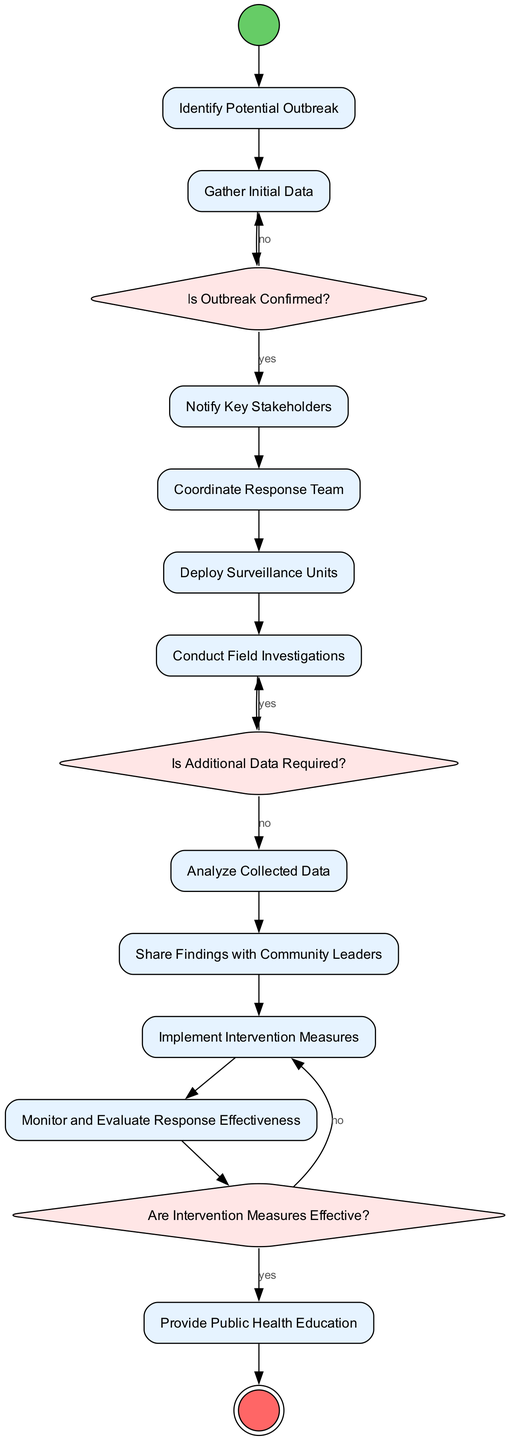What is the initial action in the diagram? The diagram starts with the node "Identify Potential Outbreak," indicating it is the first action taken in the response coordination process.
Answer: Identify Potential Outbreak How many decision nodes are in the diagram? The diagram contains three decision nodes: "Is Outbreak Confirmed?", "Is Additional Data Required?", and "Are Intervention Measures Effective?". Thus, the total count is three.
Answer: 3 What follows after "Notify Key Stakeholders"? According to the flow of the diagram, after "Notify Key Stakeholders," the next action is "Coordinate Response Team". This shows the sequential step in outbreak response coordination.
Answer: Coordinate Response Team If "Is Outbreak Confirmed?" returns yes, what is the next action? When "Is Outbreak Confirmed?" returns yes, the flow leads to "Notify Key Stakeholders". This means that confirmation of an outbreak initiates the notification process for stakeholders.
Answer: Notify Key Stakeholders What is the last action before the final node? The last action leading up to the final node "Provide Public Health Education" is "Are Intervention Measures Effective?" which determines the effectiveness before finalizing the education step.
Answer: Are Intervention Measures Effective? If "Is Additional Data Required?" returns yes, which action occurs next? If "Is Additional Data Required?" yields a yes, the next action is to "Conduct Field Investigations". This indicates the need for further data necessitates additional fieldwork.
Answer: Conduct Field Investigations How many total actions are described in the diagram? There are eleven distinct actions listed in the diagram, signifying the steps involved in the community outbreak response coordination process.
Answer: 11 What happens if "Are Intervention Measures Effective?" returns no? If "Are Intervention Measures Effective?" returns no, the flow indicates to "Implement Intervention Measures" again which suggests a reevaluation or modification of the measures.
Answer: Implement Intervention Measures 